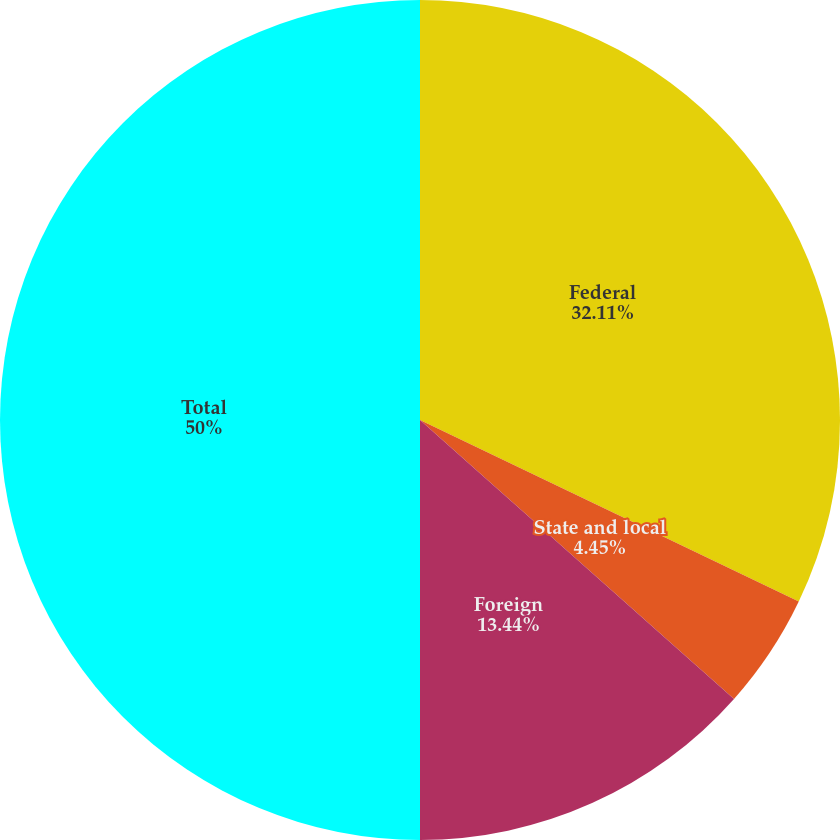Convert chart to OTSL. <chart><loc_0><loc_0><loc_500><loc_500><pie_chart><fcel>Federal<fcel>State and local<fcel>Foreign<fcel>Total<nl><fcel>32.11%<fcel>4.45%<fcel>13.44%<fcel>50.0%<nl></chart> 